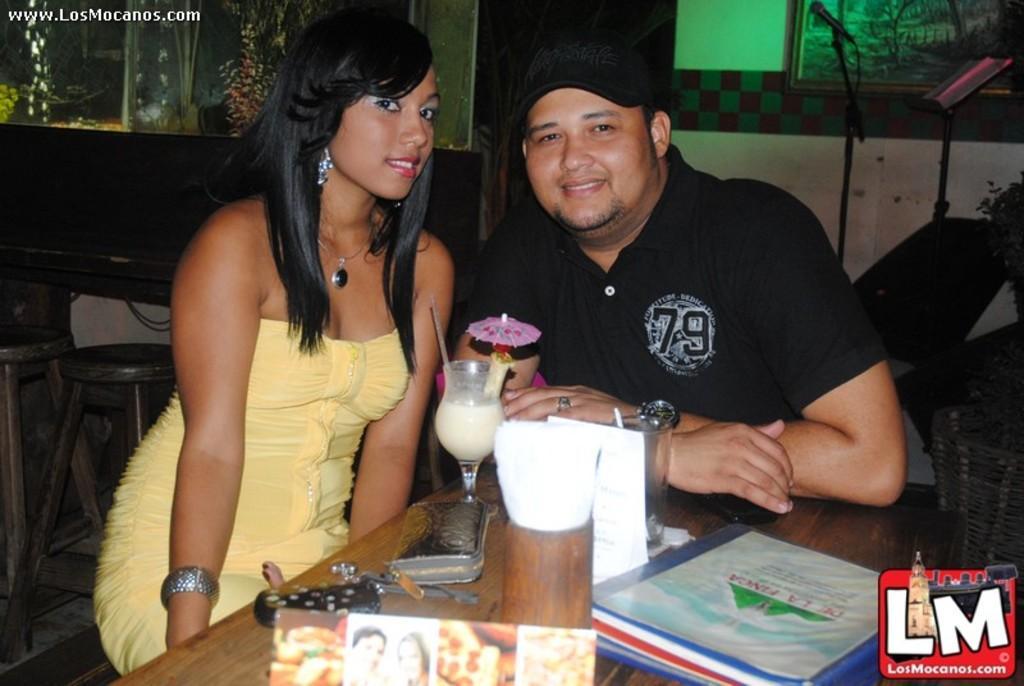How would you summarize this image in a sentence or two? In this image in the front there is a table, on the table there are books, glasses and there is a photo frame. In the center there are persons sitting and smiling. In the background there are empty stools, there is an aquarium and there is a mic with a stand and there is a frame on the wall. 